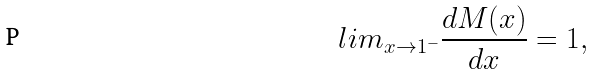Convert formula to latex. <formula><loc_0><loc_0><loc_500><loc_500>l i m _ { x \rightarrow 1 ^ { - } } \frac { d M ( x ) } { d x } = 1 ,</formula> 